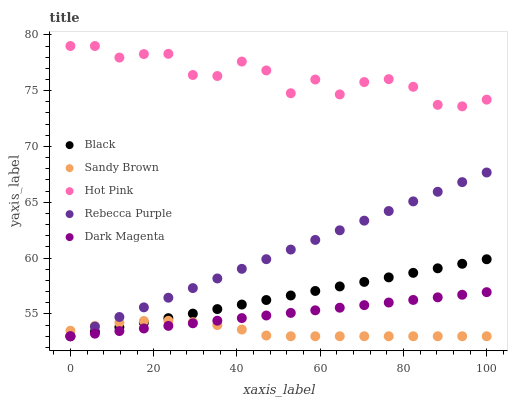Does Sandy Brown have the minimum area under the curve?
Answer yes or no. Yes. Does Hot Pink have the maximum area under the curve?
Answer yes or no. Yes. Does Black have the minimum area under the curve?
Answer yes or no. No. Does Black have the maximum area under the curve?
Answer yes or no. No. Is Dark Magenta the smoothest?
Answer yes or no. Yes. Is Hot Pink the roughest?
Answer yes or no. Yes. Is Black the smoothest?
Answer yes or no. No. Is Black the roughest?
Answer yes or no. No. Does Sandy Brown have the lowest value?
Answer yes or no. Yes. Does Hot Pink have the lowest value?
Answer yes or no. No. Does Hot Pink have the highest value?
Answer yes or no. Yes. Does Black have the highest value?
Answer yes or no. No. Is Dark Magenta less than Hot Pink?
Answer yes or no. Yes. Is Hot Pink greater than Dark Magenta?
Answer yes or no. Yes. Does Rebecca Purple intersect Sandy Brown?
Answer yes or no. Yes. Is Rebecca Purple less than Sandy Brown?
Answer yes or no. No. Is Rebecca Purple greater than Sandy Brown?
Answer yes or no. No. Does Dark Magenta intersect Hot Pink?
Answer yes or no. No. 